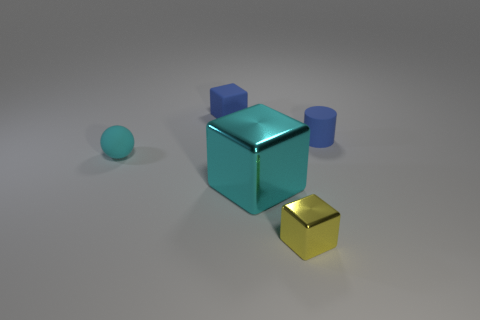Add 4 tiny metallic things. How many objects exist? 9 Subtract all cylinders. How many objects are left? 4 Add 4 metal cubes. How many metal cubes are left? 6 Add 2 cyan cubes. How many cyan cubes exist? 3 Subtract 0 green cylinders. How many objects are left? 5 Subtract all tiny brown metallic blocks. Subtract all cyan blocks. How many objects are left? 4 